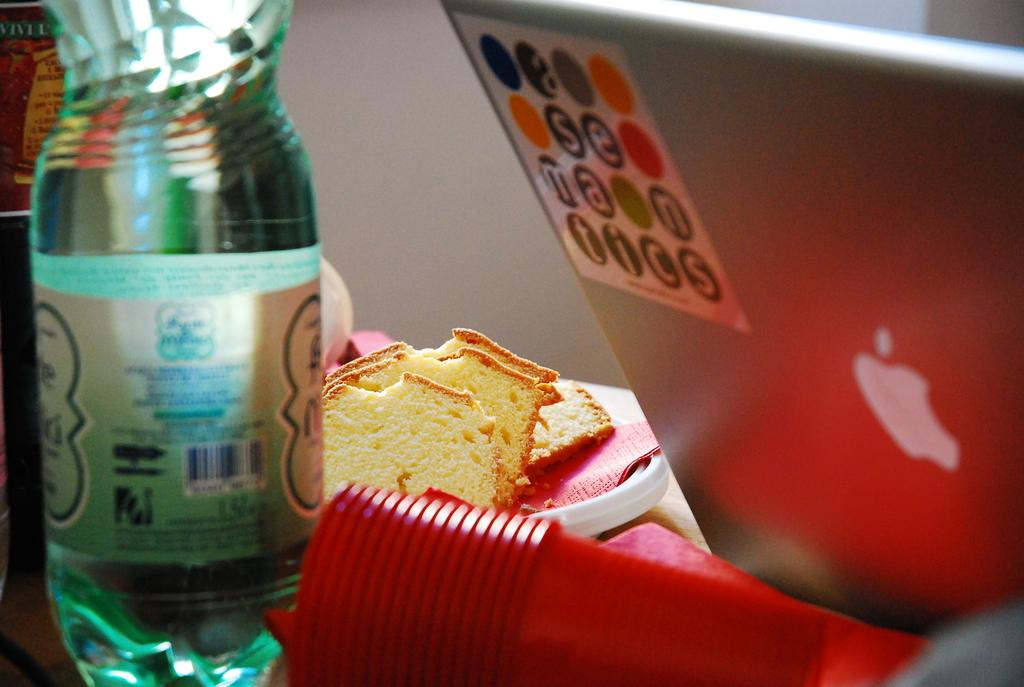What electronic device is visible in the image? There is a laptop in the image. What accessory is present in the image? Glasses are present in the image. What type of container is in the image? There is a bottle in the image. What type of food is on the plate in the image? There is a plate with bread pieces in the image. On which side of the image is the laptop located? The laptop is on the right side of the image. What type of vacation is being planned on the laptop in the image? There is no information in the image to suggest that a vacation is being planned on the laptop. 